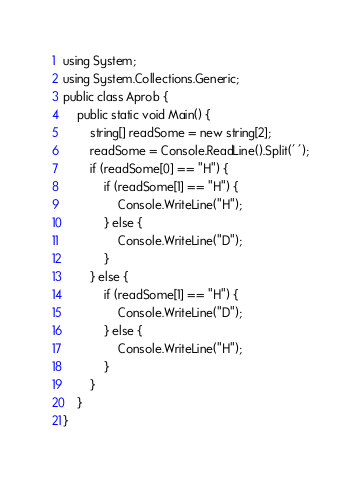<code> <loc_0><loc_0><loc_500><loc_500><_C#_>using System;
using System.Collections.Generic;
public class Aprob {
    public static void Main() {
        string[] readSome = new string[2];
        readSome = Console.ReadLine().Split(' ');
        if (readSome[0] == "H") {
            if (readSome[1] == "H") {
                Console.WriteLine("H");
            } else {
                Console.WriteLine("D");
            }
        } else {
            if (readSome[1] == "H") {
                Console.WriteLine("D");
            } else {
                Console.WriteLine("H");
            }
        }
    }
}</code> 